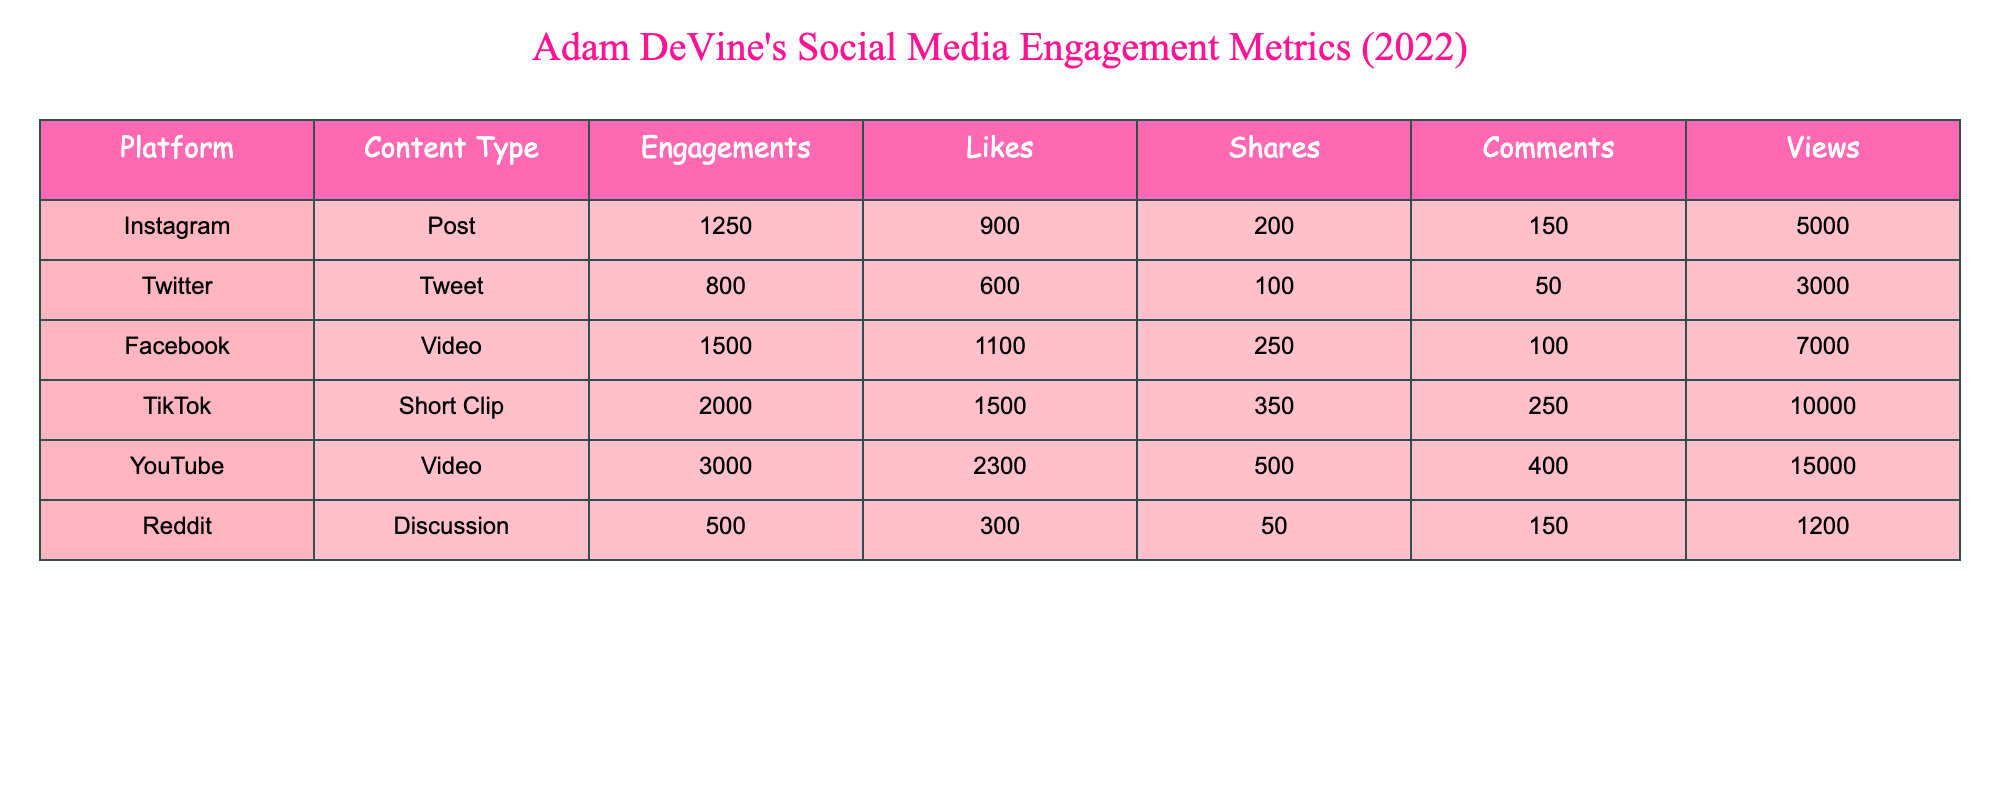What platform had the highest number of engagements for Adam DeVine-related content? By reviewing the engagement metrics in the table, we see that TikTok has 2000 engagements, while the others have fewer: Instagram has 1250, Twitter has 800, Facebook has 1500, YouTube has 3000, and Reddit has 500.
Answer: YouTube Which content type received the most likes? Examining the Likes column, we find: Instagram has 900 likes, Twitter has 600, Facebook has 1100, TikTok has 1500, YouTube has 2300, and Reddit has 300. The highest value is YouTube with 2300 likes.
Answer: YouTube What is the total number of shares across all platforms for Adam DeVine-related content? Adding the shares from each platform provides the total: 200 (Instagram) + 100 (Twitter) + 250 (Facebook) + 350 (TikTok) + 500 (YouTube) + 50 (Reddit) = 1550 shares.
Answer: 1550 Did TikTok have more views than Instagram? According to the Views column, TikTok has 10000 views while Instagram has only 5000 views. Therefore, TikTok does have more views than Instagram.
Answer: Yes What is the average number of comments per platform? To calculate the average comments, we first sum the comments: 150 (Instagram) + 50 (Twitter) + 100 (Facebook) + 250 (TikTok) + 400 (YouTube) + 150 (Reddit) = 1100 comments. Then we divide by the number of platforms (6): 1100 / 6 ≈ 183.33, so approximately 183 comments.
Answer: 183 Which platform had the least total engagements? Looking at the Engagements column, the values are: Instagram (1250), Twitter (800), Facebook (1500), TikTok (2000), YouTube (3000), and Reddit (500). The least is 500 from Reddit.
Answer: Reddit How many more views did YouTube have than Facebook? To find the difference in views between YouTube and Facebook, we take YouTube's views (15000) and subtract Facebook's views (7000): 15000 - 7000 = 8000.
Answer: 8000 Which platform had the highest engagement rate, given the formula Engagements/Views for each? The engagement rates are calculated as follows: 
- Instagram: 1250/5000 = 0.25 
- Twitter: 800/3000 ≈ 0.267 
- Facebook: 1500/7000 ≈ 0.214 
- TikTok: 2000/10000 = 0.2 
- YouTube: 3000/15000 = 0.2 
- Reddit: 500/1200 ≈ 0.417
The highest engagement rate is from Reddit with approximately 0.417.
Answer: Reddit 